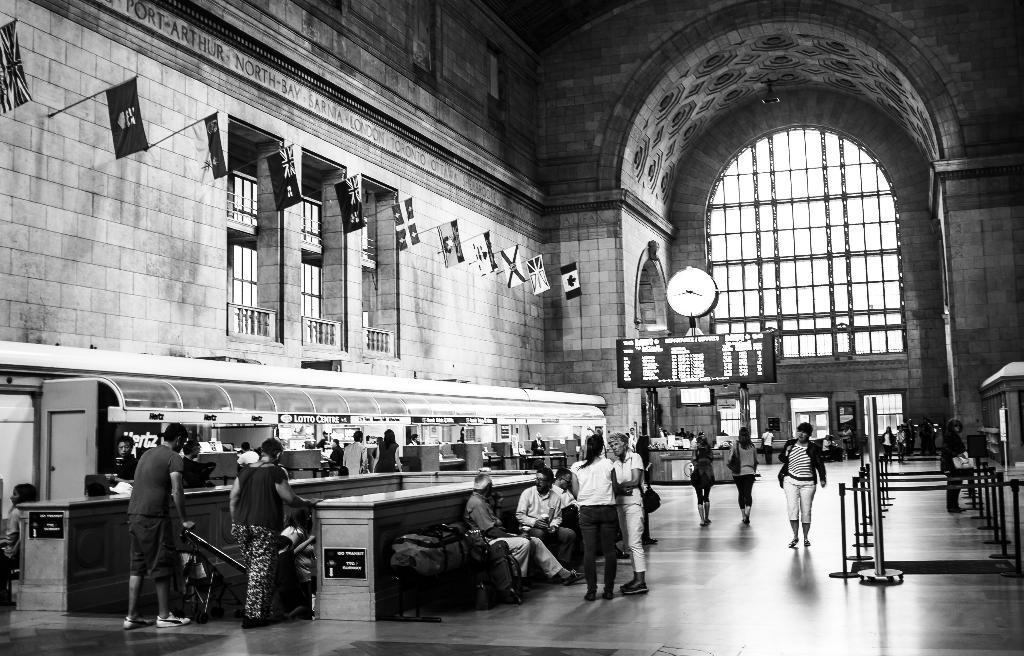Can you describe this image briefly? This is a black and white image. In the center of the image there are people. To the left side of the image there is a wall with flags. There is a clock. In the background of the image there is arch. There is a glass wall. 